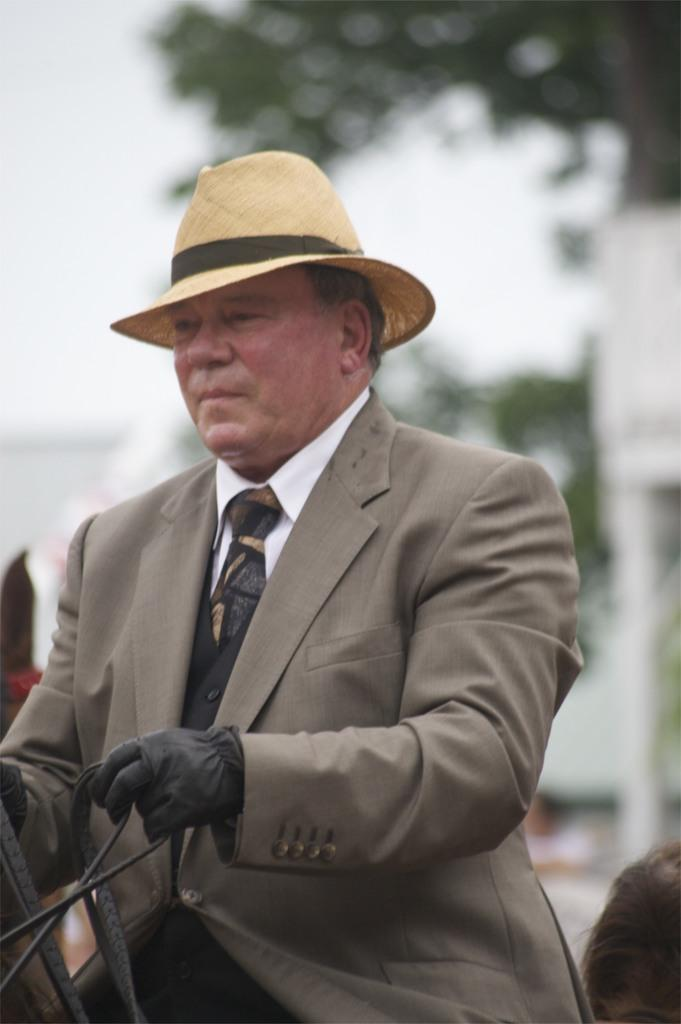What can be seen in the image? There is a person in the image. What is the person wearing? The person is wearing a hat and gloves. What is the person holding? The person is holding a rope. What is the condition of the background in the image? The background of the image is blurry. Can you describe the presence of another person in the image? There is a head of another person near the main person. Is there a kitten playing with smoke coming out of a tub in the image? No, there is no kitten, smoke, or tub present in the image. 